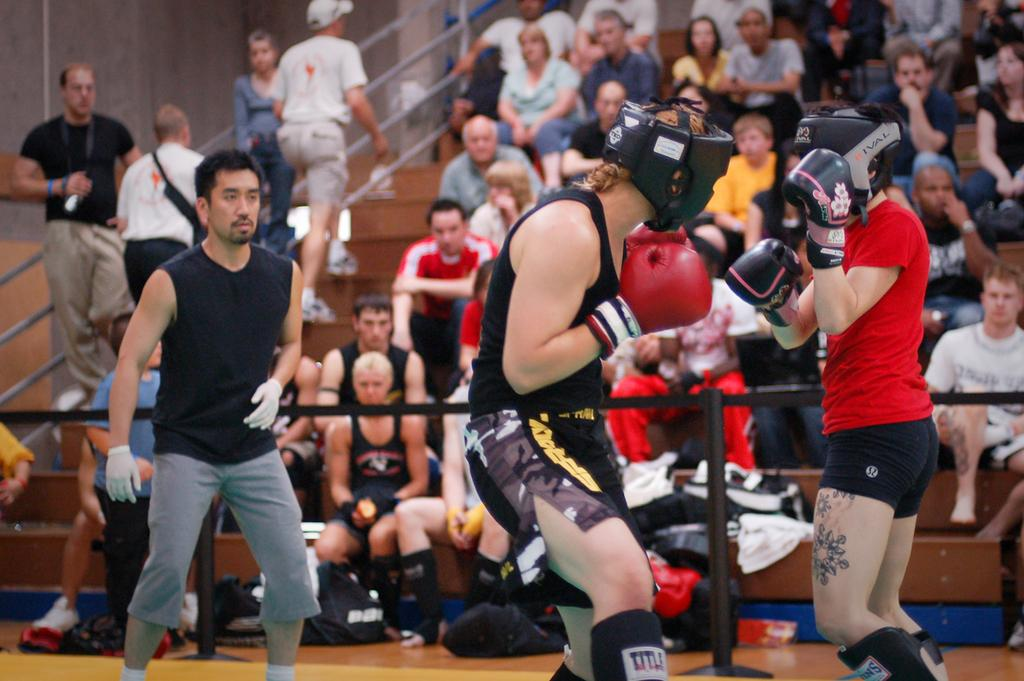How many people are in the image? There are people in the image. What are some of the people doing in the image? Some people are walking on the stairs, and two people are boxing. What objects can be seen on the floor in the image? There are bags on the floor. What type of structure is present in the image? There is a wall in the image. What feature is present to assist with climbing or descending the stairs? There is a handrail in the image. What type of letter is the father writing in the image? There is no father or letter present in the image. How many pies are visible on the wall in the image? There are no pies visible in the image; the wall is not mentioned as having any pies. 